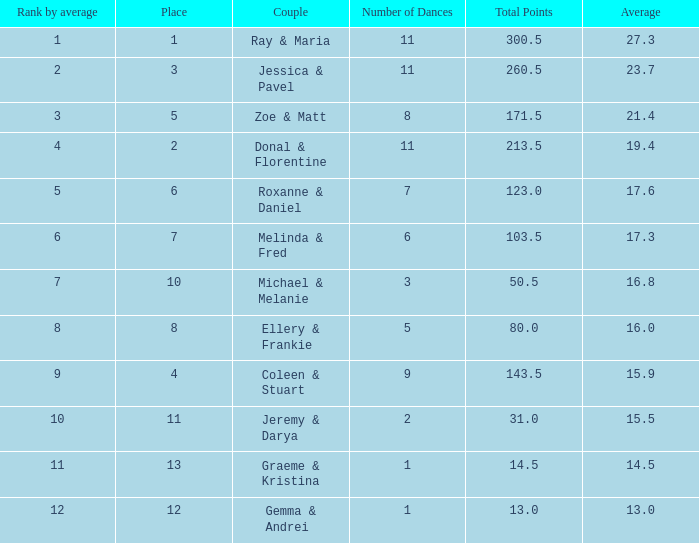What is the duo's name having a mean of 1 Coleen & Stuart. 